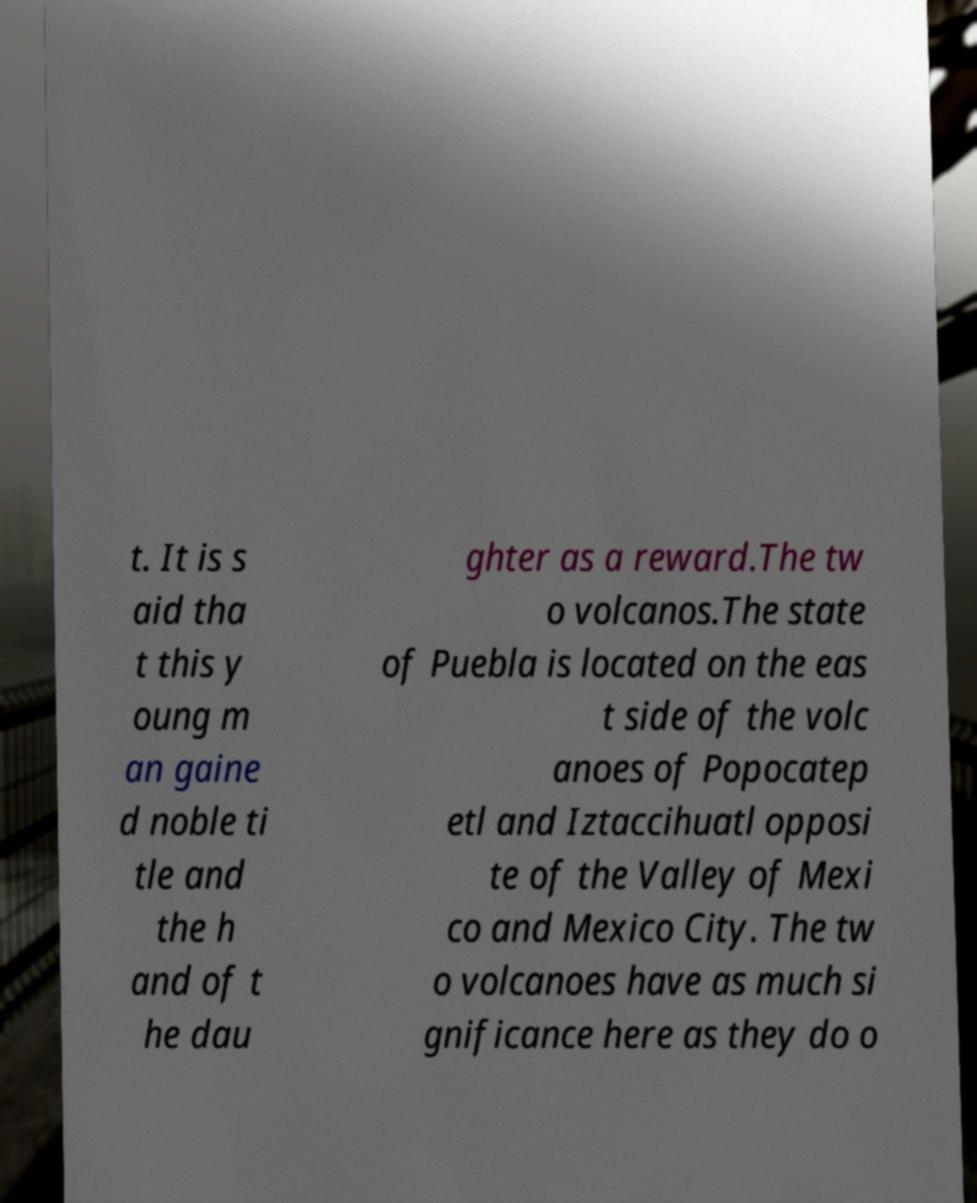Please identify and transcribe the text found in this image. t. It is s aid tha t this y oung m an gaine d noble ti tle and the h and of t he dau ghter as a reward.The tw o volcanos.The state of Puebla is located on the eas t side of the volc anoes of Popocatep etl and Iztaccihuatl opposi te of the Valley of Mexi co and Mexico City. The tw o volcanoes have as much si gnificance here as they do o 